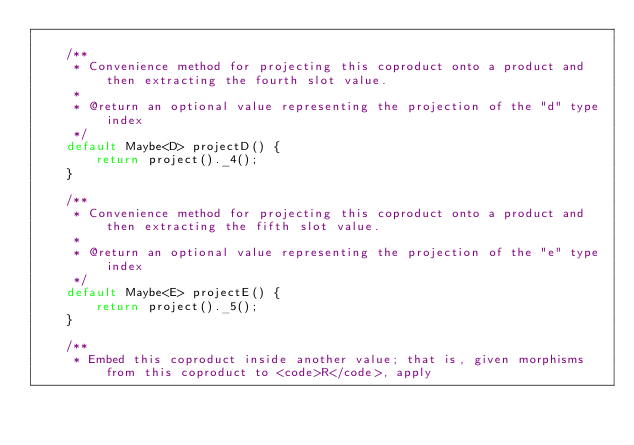Convert code to text. <code><loc_0><loc_0><loc_500><loc_500><_Java_>
    /**
     * Convenience method for projecting this coproduct onto a product and then extracting the fourth slot value.
     *
     * @return an optional value representing the projection of the "d" type index
     */
    default Maybe<D> projectD() {
        return project()._4();
    }

    /**
     * Convenience method for projecting this coproduct onto a product and then extracting the fifth slot value.
     *
     * @return an optional value representing the projection of the "e" type index
     */
    default Maybe<E> projectE() {
        return project()._5();
    }

    /**
     * Embed this coproduct inside another value; that is, given morphisms from this coproduct to <code>R</code>, apply</code> 